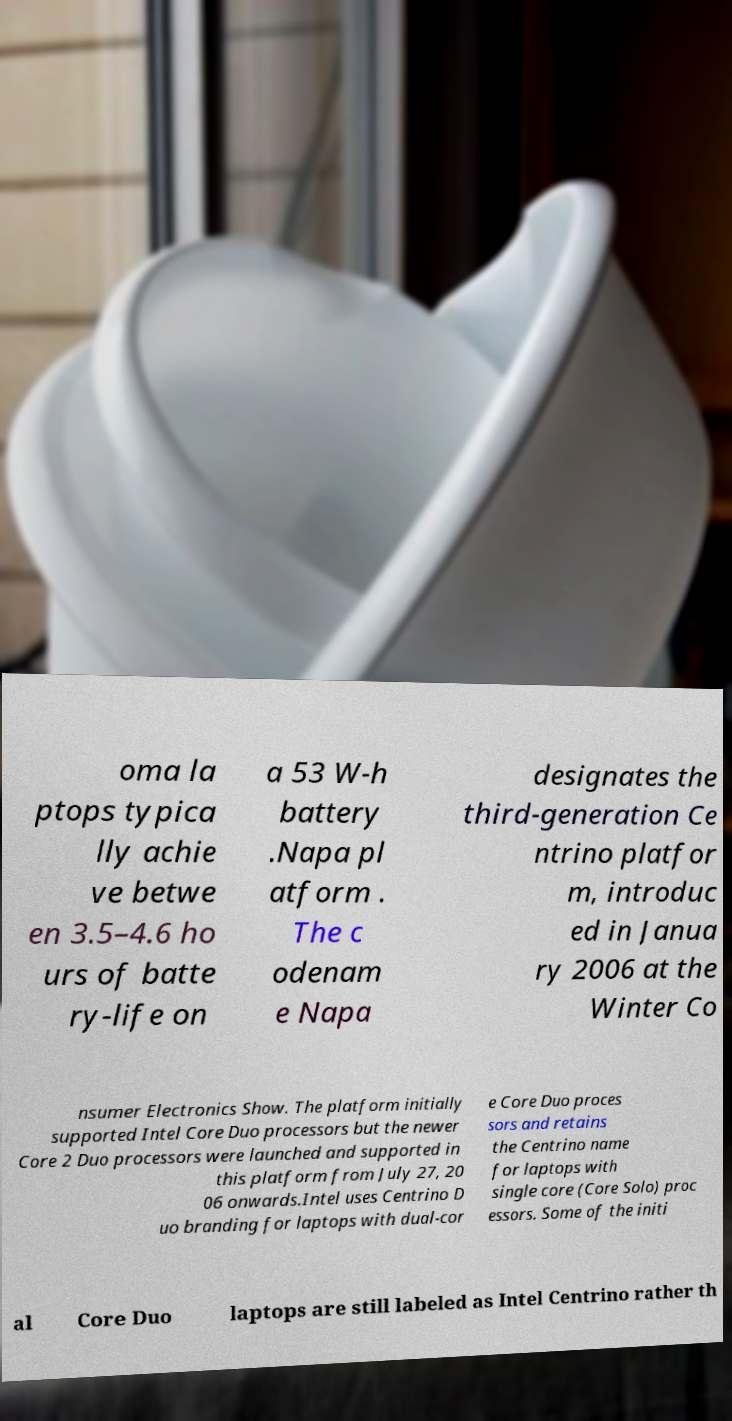Please identify and transcribe the text found in this image. oma la ptops typica lly achie ve betwe en 3.5–4.6 ho urs of batte ry-life on a 53 W-h battery .Napa pl atform . The c odenam e Napa designates the third-generation Ce ntrino platfor m, introduc ed in Janua ry 2006 at the Winter Co nsumer Electronics Show. The platform initially supported Intel Core Duo processors but the newer Core 2 Duo processors were launched and supported in this platform from July 27, 20 06 onwards.Intel uses Centrino D uo branding for laptops with dual-cor e Core Duo proces sors and retains the Centrino name for laptops with single core (Core Solo) proc essors. Some of the initi al Core Duo laptops are still labeled as Intel Centrino rather th 